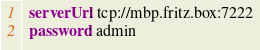<code> <loc_0><loc_0><loc_500><loc_500><_YAML_>  serverUrl: tcp://mbp.fritz.box:7222
  password: admin</code> 